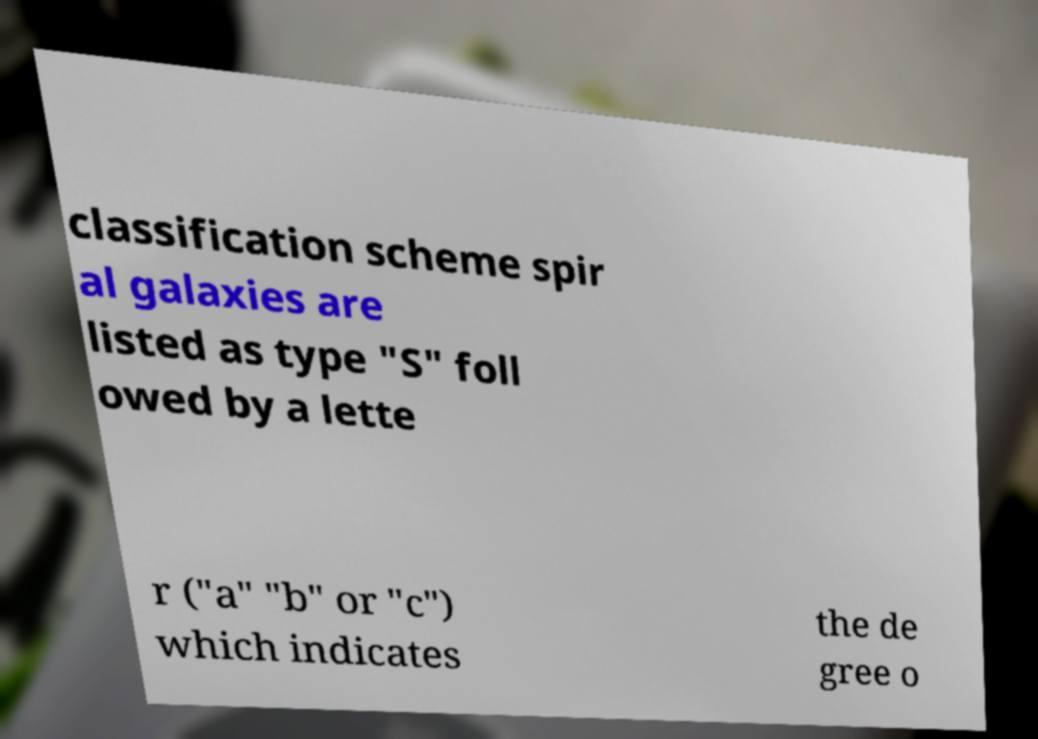Can you accurately transcribe the text from the provided image for me? classification scheme spir al galaxies are listed as type "S" foll owed by a lette r ("a" "b" or "c") which indicates the de gree o 